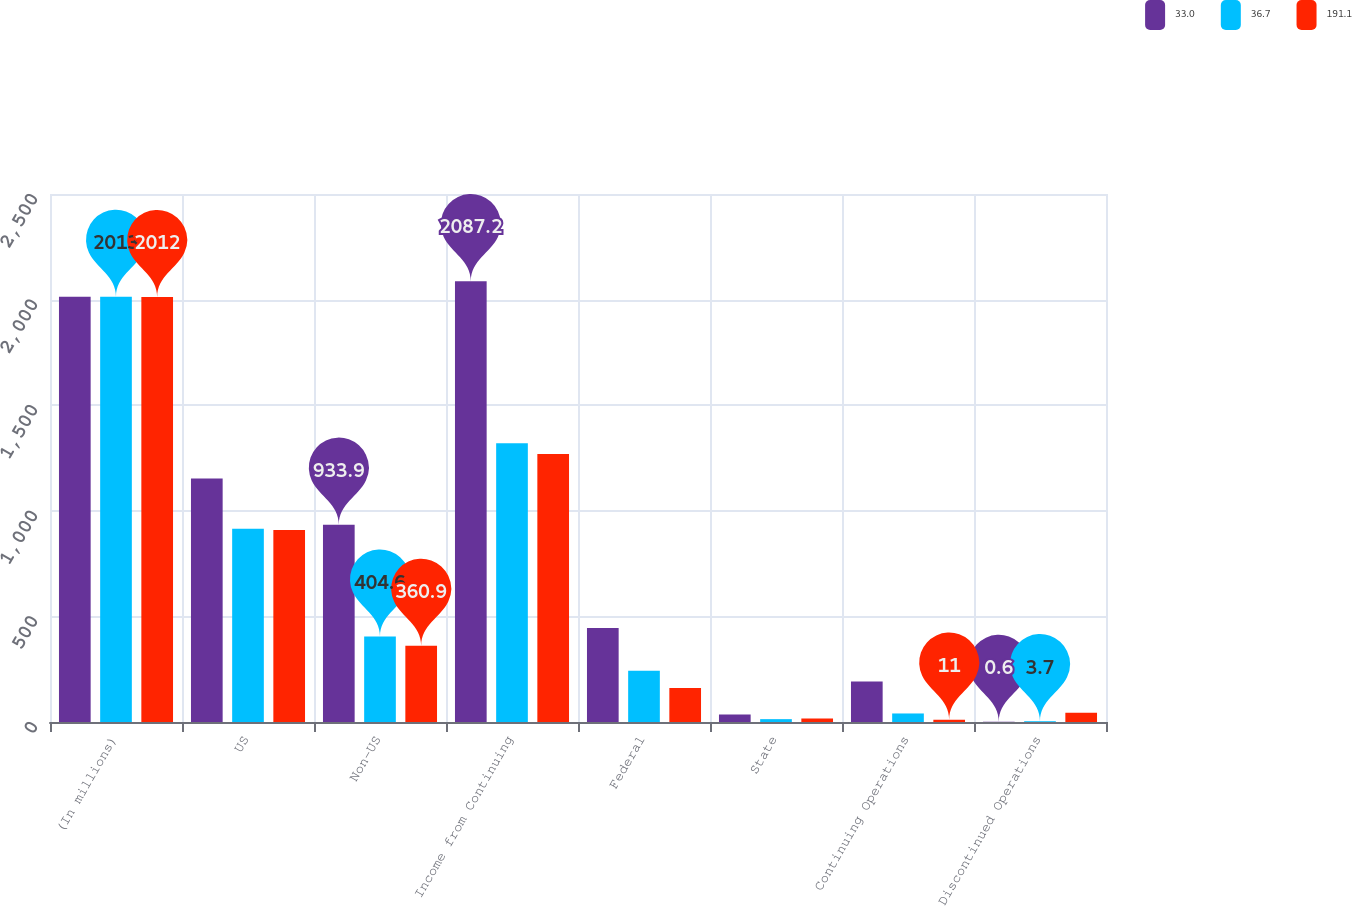Convert chart to OTSL. <chart><loc_0><loc_0><loc_500><loc_500><stacked_bar_chart><ecel><fcel>(In millions)<fcel>US<fcel>Non-US<fcel>Income from Continuing<fcel>Federal<fcel>State<fcel>Continuing Operations<fcel>Discontinued Operations<nl><fcel>33<fcel>2014<fcel>1153.3<fcel>933.9<fcel>2087.2<fcel>444.5<fcel>35<fcel>191.7<fcel>0.6<nl><fcel>36.7<fcel>2013<fcel>914.9<fcel>404.6<fcel>1319.5<fcel>242.5<fcel>13.5<fcel>40.4<fcel>3.7<nl><fcel>191.1<fcel>2012<fcel>908.5<fcel>360.9<fcel>1269.4<fcel>160.5<fcel>16.1<fcel>11<fcel>44<nl></chart> 